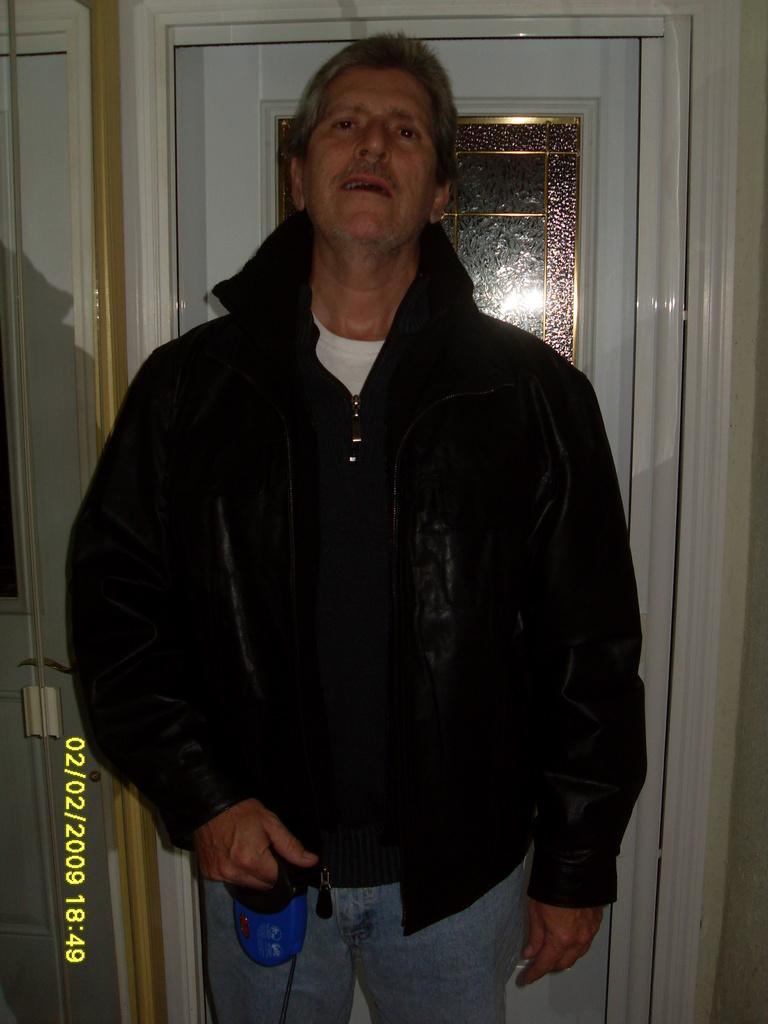What can be seen in the image? There is a person in the image. What is the person holding in their hand? The person is holding something in their hand, but the specific object is not mentioned in the facts. What is the person wearing? The person is wearing a black jacket. What is visible in the background of the image? There is a door in the background of the image. What type of plant is growing out of the wheel in the image? There is no wheel or plant present in the image. 